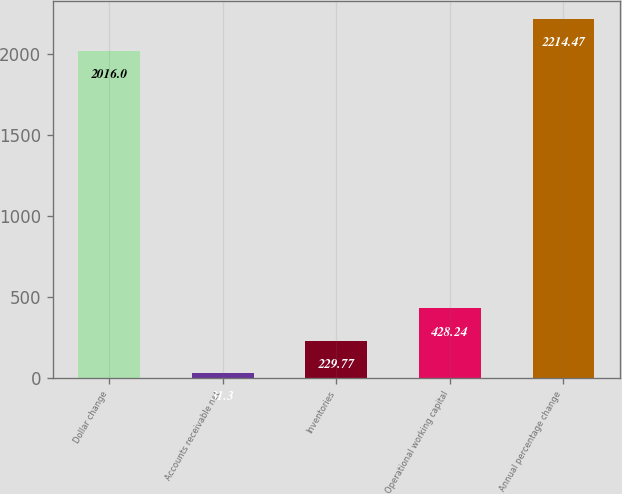Convert chart to OTSL. <chart><loc_0><loc_0><loc_500><loc_500><bar_chart><fcel>Dollar change<fcel>Accounts receivable net<fcel>Inventories<fcel>Operational working capital<fcel>Annual percentage change<nl><fcel>2016<fcel>31.3<fcel>229.77<fcel>428.24<fcel>2214.47<nl></chart> 